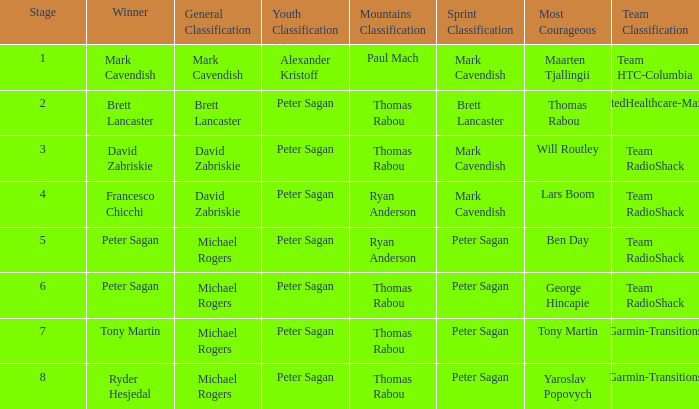Can you give me this table as a dict? {'header': ['Stage', 'Winner', 'General Classification', 'Youth Classification', 'Mountains Classification', 'Sprint Classification', 'Most Courageous', 'Team Classification'], 'rows': [['1', 'Mark Cavendish', 'Mark Cavendish', 'Alexander Kristoff', 'Paul Mach', 'Mark Cavendish', 'Maarten Tjallingii', 'Team HTC-Columbia'], ['2', 'Brett Lancaster', 'Brett Lancaster', 'Peter Sagan', 'Thomas Rabou', 'Brett Lancaster', 'Thomas Rabou', 'UnitedHealthcare-Maxxis'], ['3', 'David Zabriskie', 'David Zabriskie', 'Peter Sagan', 'Thomas Rabou', 'Mark Cavendish', 'Will Routley', 'Team RadioShack'], ['4', 'Francesco Chicchi', 'David Zabriskie', 'Peter Sagan', 'Ryan Anderson', 'Mark Cavendish', 'Lars Boom', 'Team RadioShack'], ['5', 'Peter Sagan', 'Michael Rogers', 'Peter Sagan', 'Ryan Anderson', 'Peter Sagan', 'Ben Day', 'Team RadioShack'], ['6', 'Peter Sagan', 'Michael Rogers', 'Peter Sagan', 'Thomas Rabou', 'Peter Sagan', 'George Hincapie', 'Team RadioShack'], ['7', 'Tony Martin', 'Michael Rogers', 'Peter Sagan', 'Thomas Rabou', 'Peter Sagan', 'Tony Martin', 'Garmin-Transitions'], ['8', 'Ryder Hesjedal', 'Michael Rogers', 'Peter Sagan', 'Thomas Rabou', 'Peter Sagan', 'Yaroslav Popovych', 'Garmin-Transitions']]} When Mark Cavendish wins sprint classification and Maarten Tjallingii wins most courageous, who wins youth classification? Alexander Kristoff. 